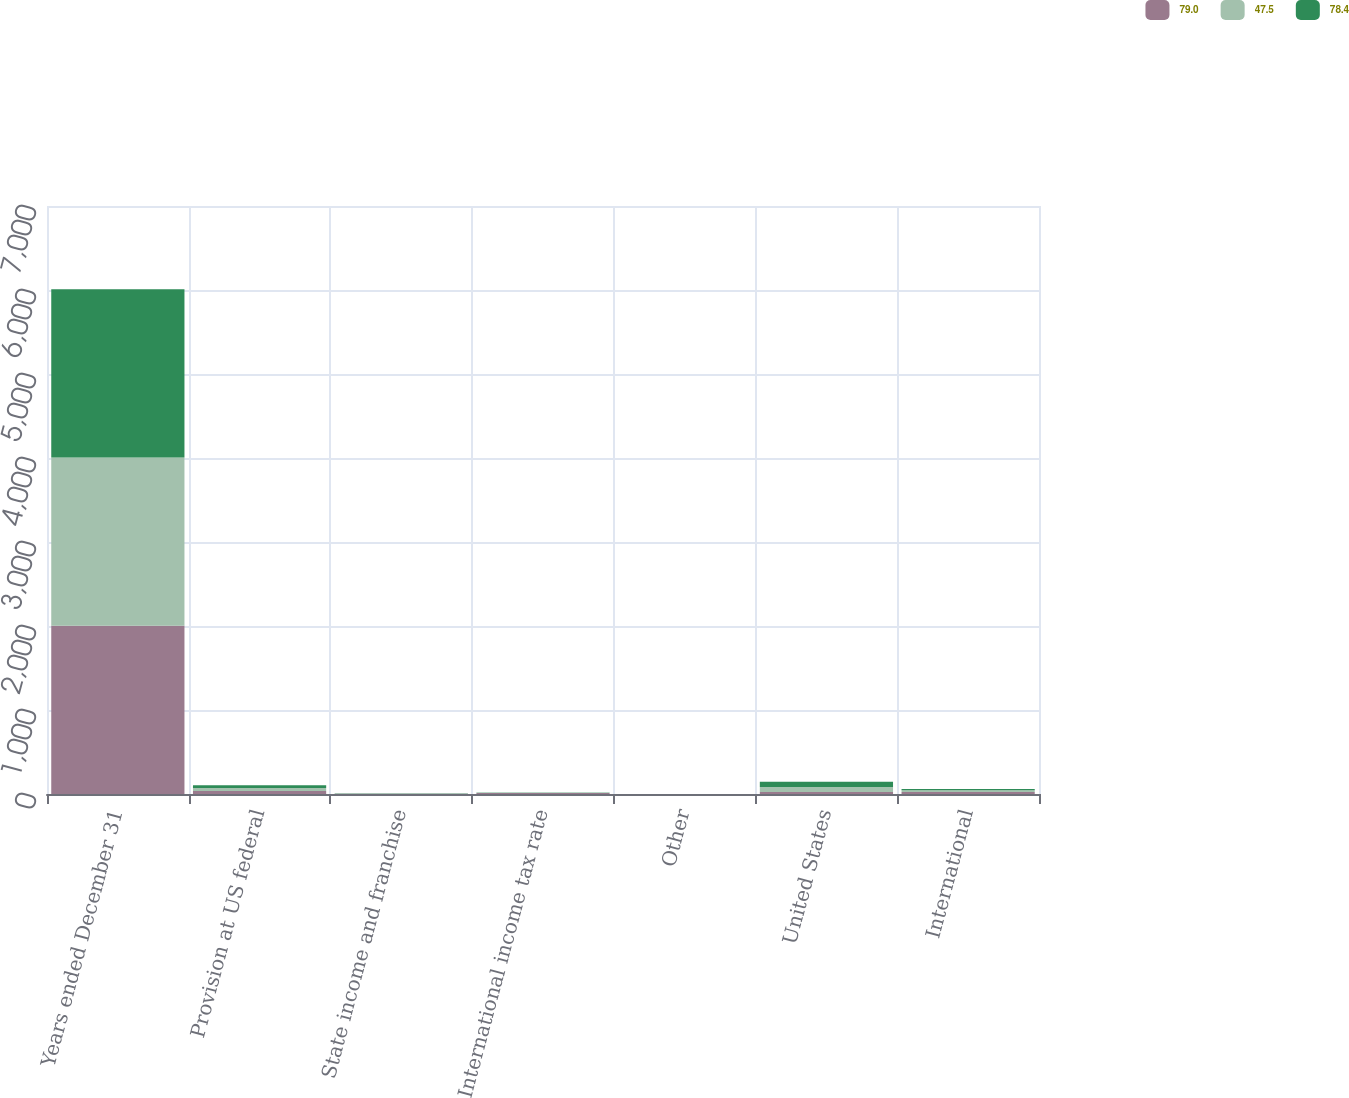Convert chart to OTSL. <chart><loc_0><loc_0><loc_500><loc_500><stacked_bar_chart><ecel><fcel>Years ended December 31<fcel>Provision at US federal<fcel>State income and franchise<fcel>International income tax rate<fcel>Other<fcel>United States<fcel>International<nl><fcel>79<fcel>2004<fcel>35<fcel>2.6<fcel>12.5<fcel>0.4<fcel>23.2<fcel>24.3<nl><fcel>47.5<fcel>2003<fcel>35<fcel>3.1<fcel>3.5<fcel>0.5<fcel>60<fcel>19<nl><fcel>78.4<fcel>2002<fcel>35<fcel>3.5<fcel>2.3<fcel>0.4<fcel>63.5<fcel>14.9<nl></chart> 